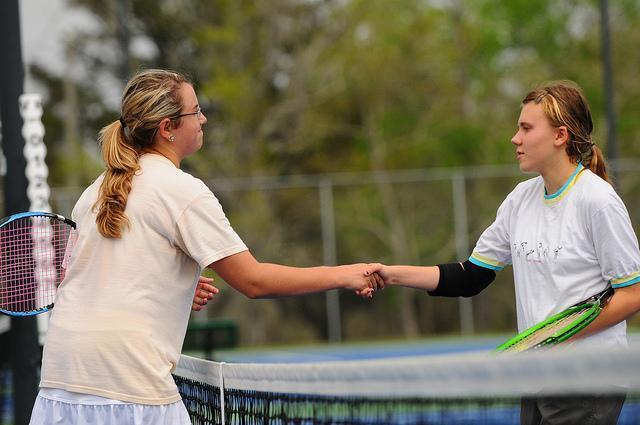How many people are visible?
Give a very brief answer. 2. How many tennis rackets are there?
Give a very brief answer. 2. 